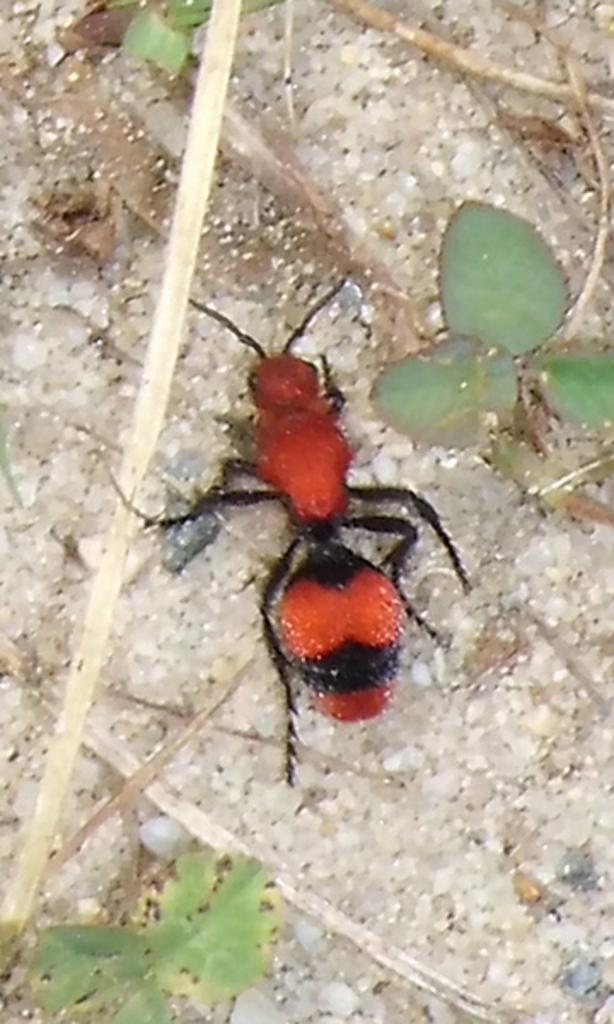What small creature can be seen in the image? There is an ant in the image. What type of vegetation is present in the image? There are plants in the image. Where are the plants located in relation to the ground? The plants are on the ground. What type of food is the ant preparing in the image? There is no indication in the image that the ant is preparing any food. 